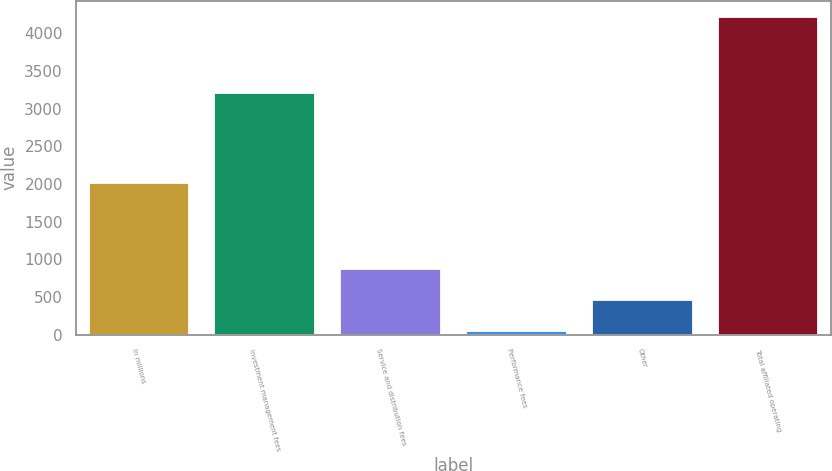<chart> <loc_0><loc_0><loc_500><loc_500><bar_chart><fcel>in millions<fcel>Investment management fees<fcel>Service and distribution fees<fcel>Performance fees<fcel>Other<fcel>Total affiliated operating<nl><fcel>2013<fcel>3208.2<fcel>878.62<fcel>44<fcel>461.31<fcel>4217.1<nl></chart> 